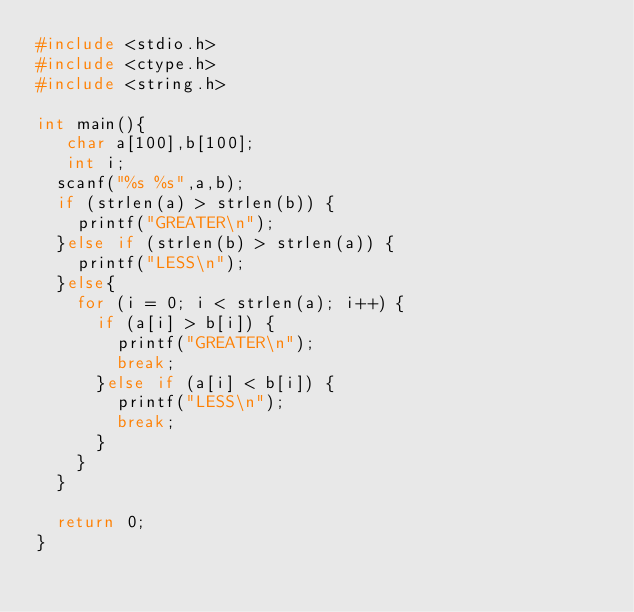Convert code to text. <code><loc_0><loc_0><loc_500><loc_500><_C_>#include <stdio.h>
#include <ctype.h>
#include <string.h>

int main(){
   char a[100],b[100];
   int i;
  scanf("%s %s",a,b);
  if (strlen(a) > strlen(b)) {
    printf("GREATER\n");
  }else if (strlen(b) > strlen(a)) {
    printf("LESS\n");
  }else{
    for (i = 0; i < strlen(a); i++) {
      if (a[i] > b[i]) {
        printf("GREATER\n");
        break;
      }else if (a[i] < b[i]) {
        printf("LESS\n");
        break;
      }
    }
  }

  return 0;
}
</code> 